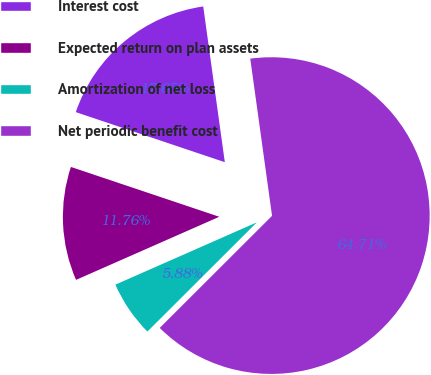<chart> <loc_0><loc_0><loc_500><loc_500><pie_chart><fcel>Interest cost<fcel>Expected return on plan assets<fcel>Amortization of net loss<fcel>Net periodic benefit cost<nl><fcel>17.65%<fcel>11.76%<fcel>5.88%<fcel>64.71%<nl></chart> 